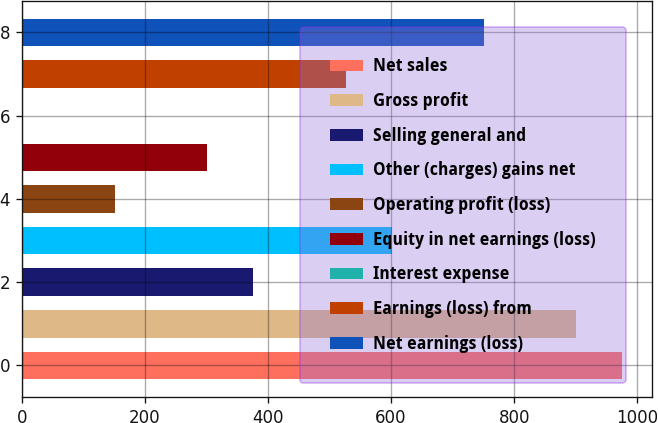Convert chart to OTSL. <chart><loc_0><loc_0><loc_500><loc_500><bar_chart><fcel>Net sales<fcel>Gross profit<fcel>Selling general and<fcel>Other (charges) gains net<fcel>Operating profit (loss)<fcel>Equity in net earnings (loss)<fcel>Interest expense<fcel>Earnings (loss) from<fcel>Net earnings (loss)<nl><fcel>975.7<fcel>900.8<fcel>376.5<fcel>601.2<fcel>151.8<fcel>301.6<fcel>2<fcel>526.3<fcel>751<nl></chart> 